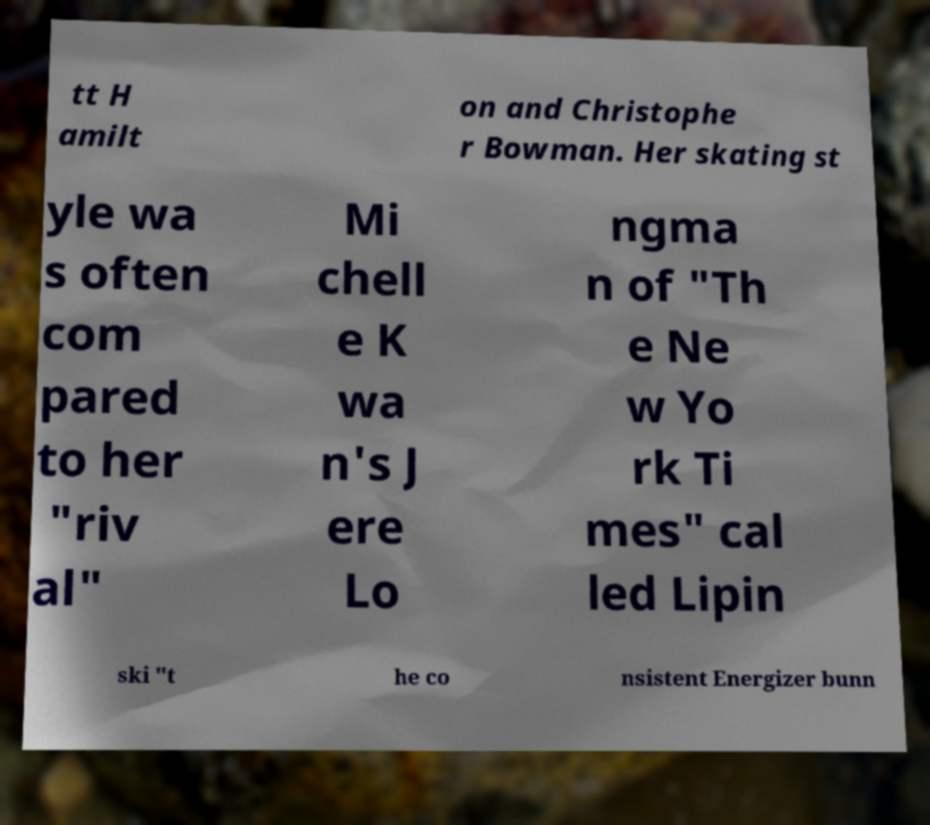Can you read and provide the text displayed in the image?This photo seems to have some interesting text. Can you extract and type it out for me? tt H amilt on and Christophe r Bowman. Her skating st yle wa s often com pared to her "riv al" Mi chell e K wa n's J ere Lo ngma n of "Th e Ne w Yo rk Ti mes" cal led Lipin ski "t he co nsistent Energizer bunn 